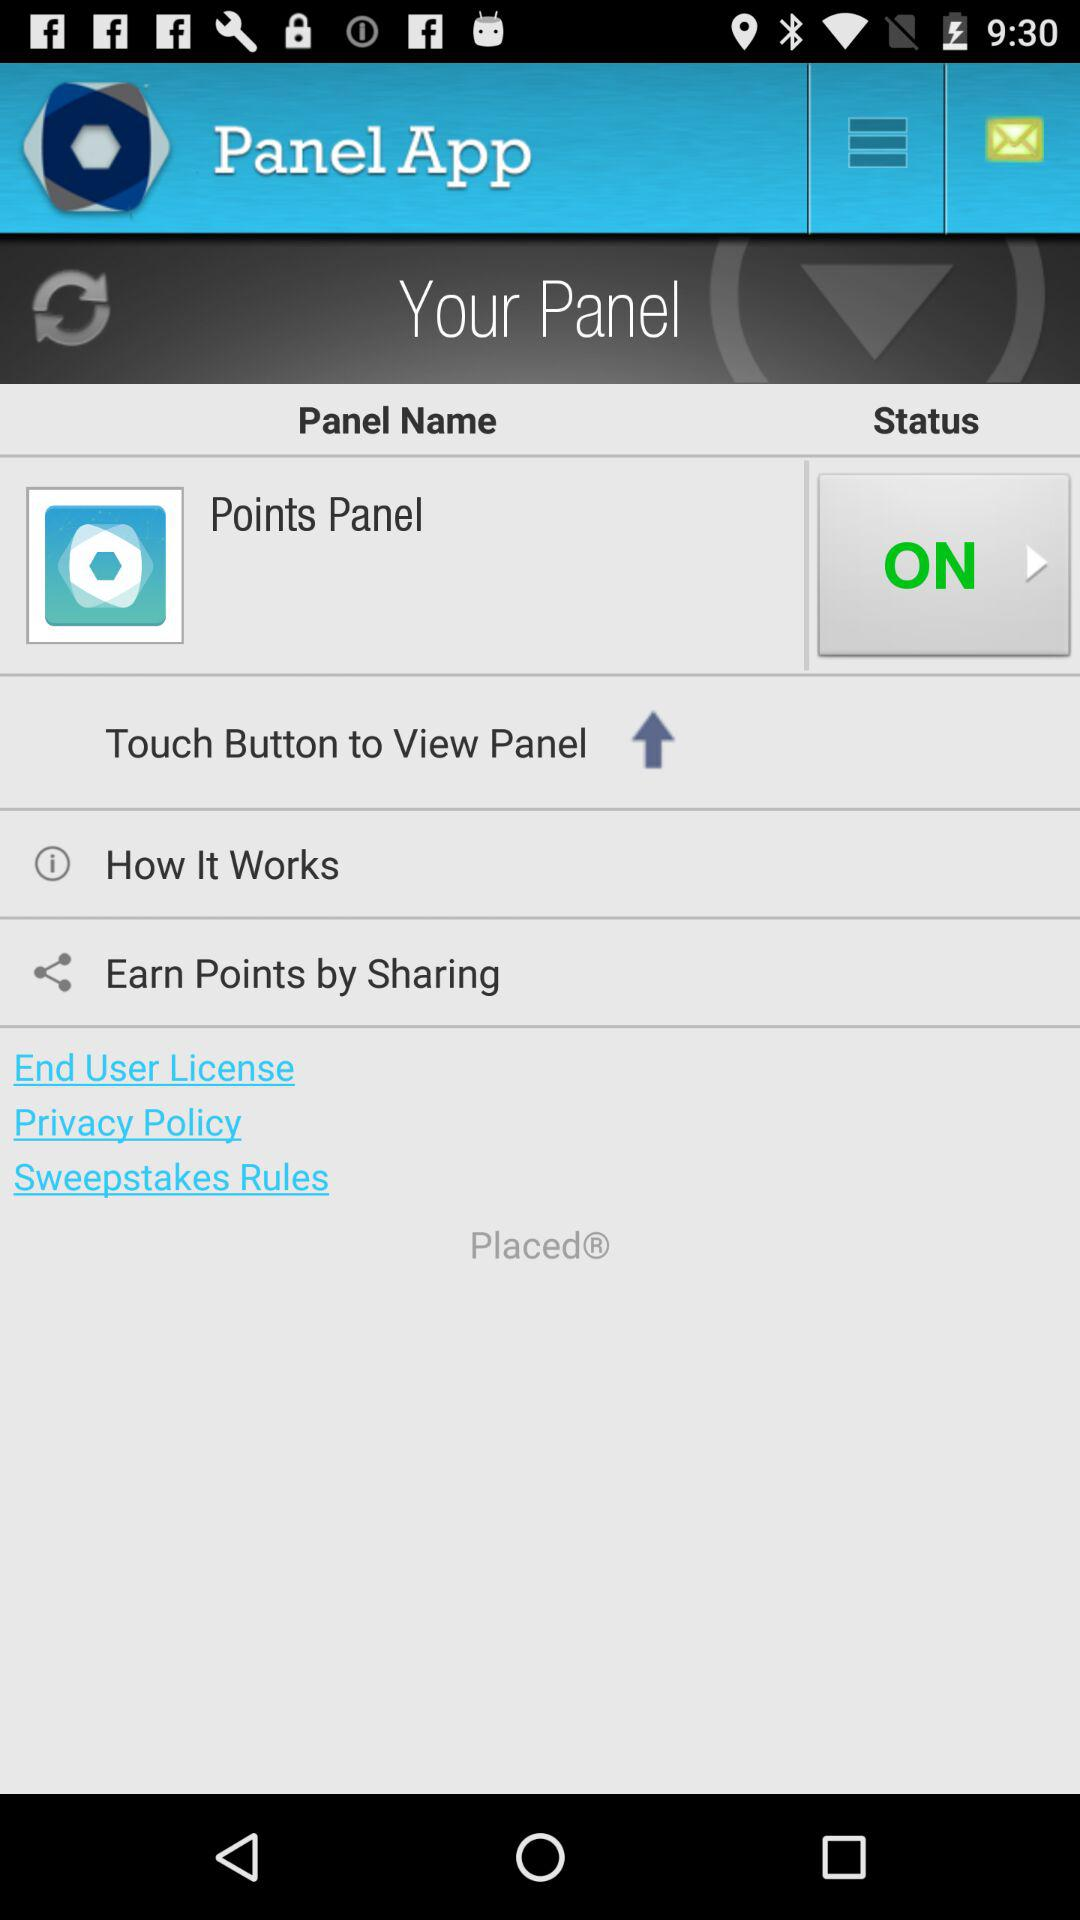What is the status of the points panel? The status is on. 